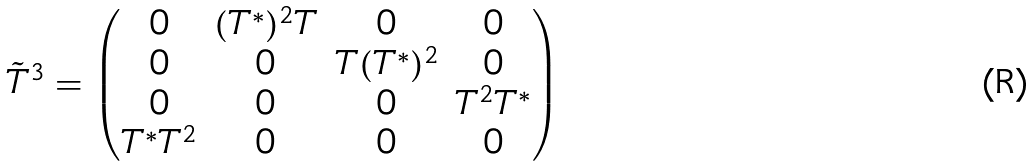<formula> <loc_0><loc_0><loc_500><loc_500>\tilde { T } ^ { 3 } = \begin{pmatrix} 0 & ( T ^ { * } ) ^ { 2 } T & 0 & 0 \\ 0 & 0 & T ( T ^ { * } ) ^ { 2 } & 0 \\ 0 & 0 & 0 & T ^ { 2 } T ^ { * } \\ T ^ { * } T ^ { 2 } & 0 & 0 & 0 \end{pmatrix}</formula> 